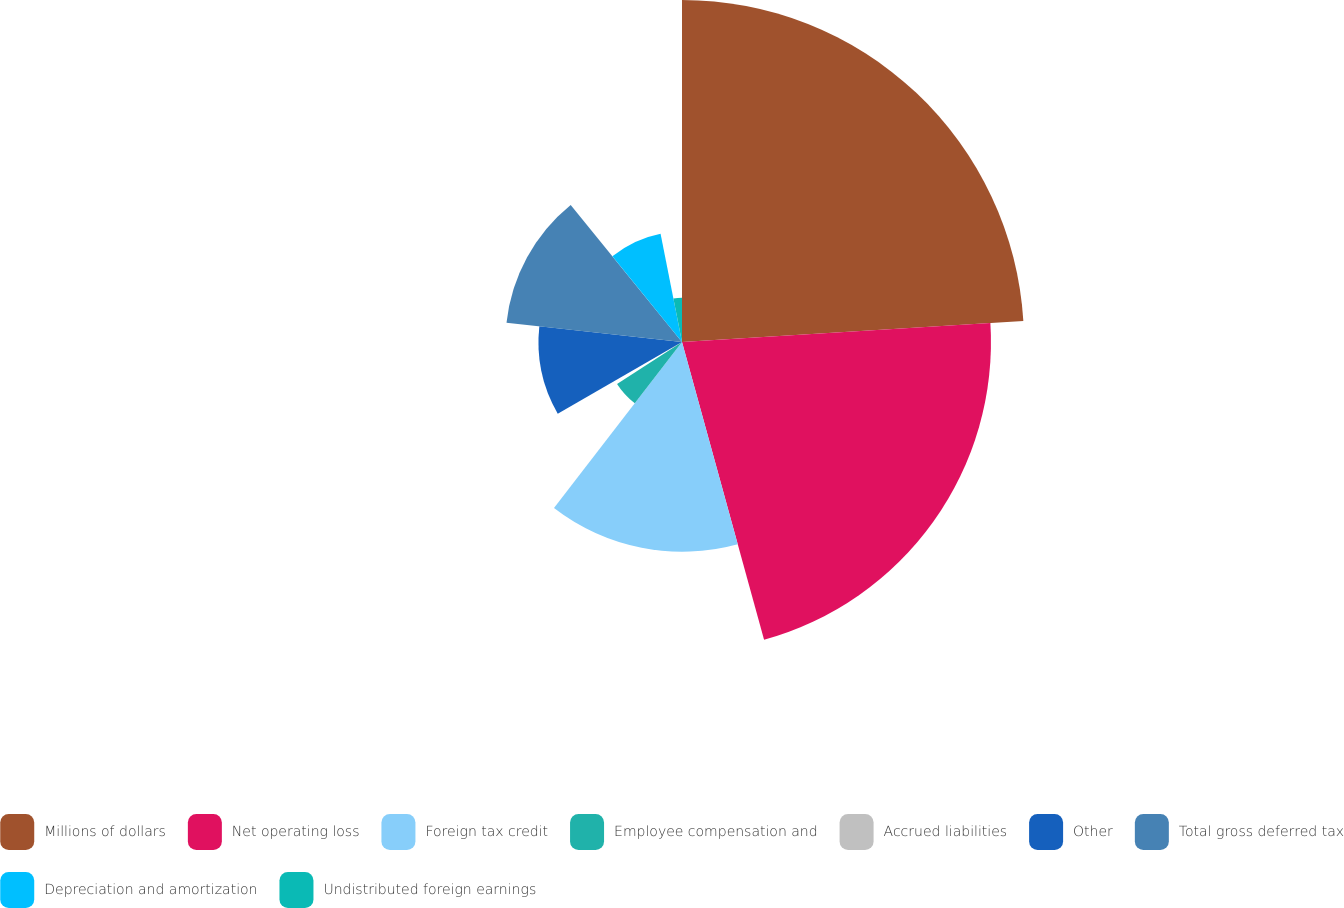Convert chart to OTSL. <chart><loc_0><loc_0><loc_500><loc_500><pie_chart><fcel>Millions of dollars<fcel>Net operating loss<fcel>Foreign tax credit<fcel>Employee compensation and<fcel>Accrued liabilities<fcel>Other<fcel>Total gross deferred tax<fcel>Depreciation and amortization<fcel>Undistributed foreign earnings<nl><fcel>24.02%<fcel>21.7%<fcel>14.73%<fcel>5.43%<fcel>0.78%<fcel>10.08%<fcel>12.4%<fcel>7.75%<fcel>3.11%<nl></chart> 